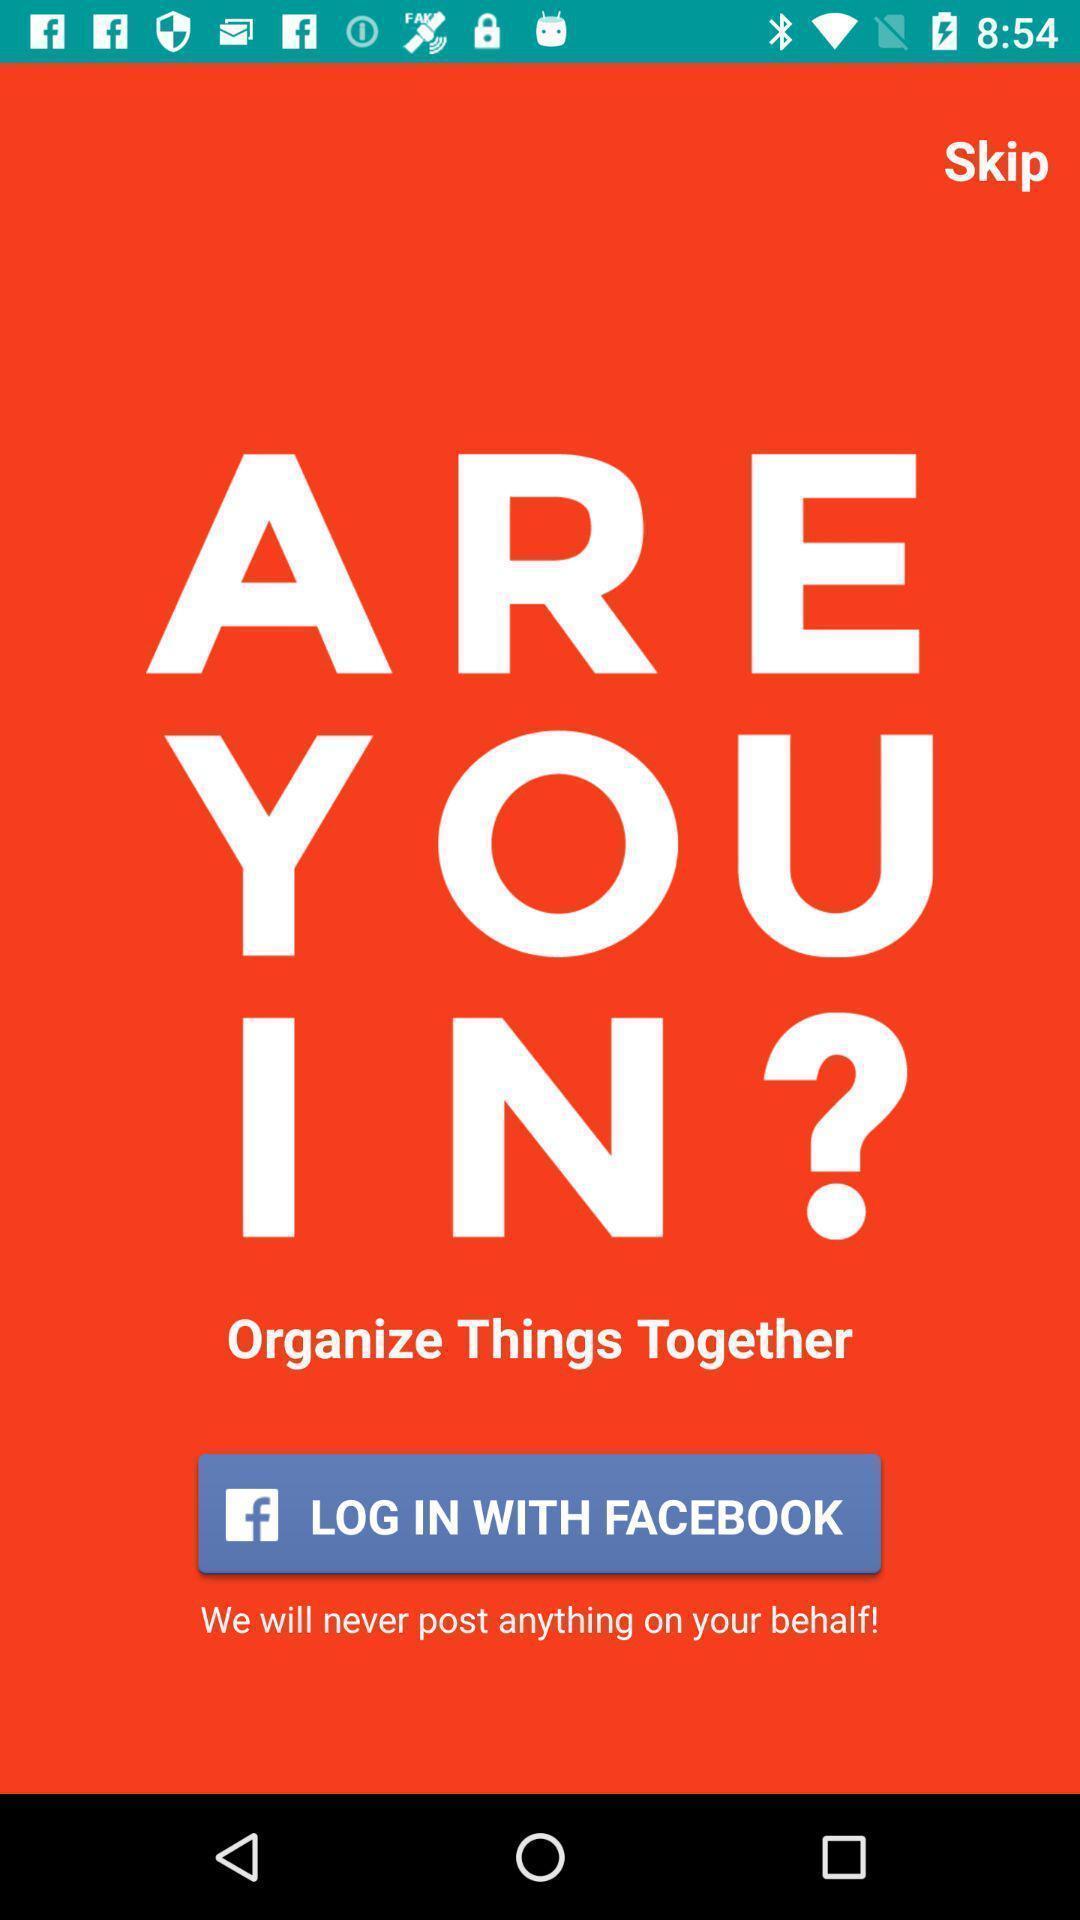What details can you identify in this image? Starting page of the game application to get access. 